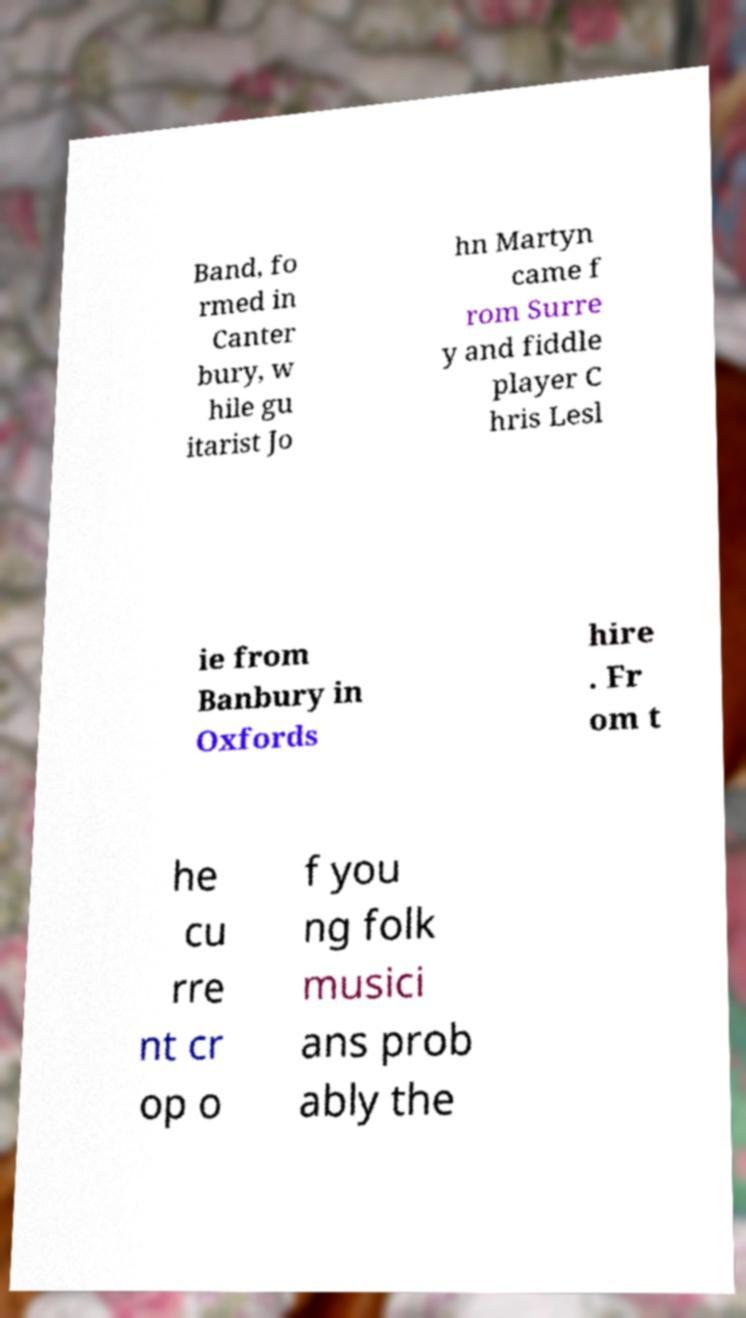Can you accurately transcribe the text from the provided image for me? Band, fo rmed in Canter bury, w hile gu itarist Jo hn Martyn came f rom Surre y and fiddle player C hris Lesl ie from Banbury in Oxfords hire . Fr om t he cu rre nt cr op o f you ng folk musici ans prob ably the 